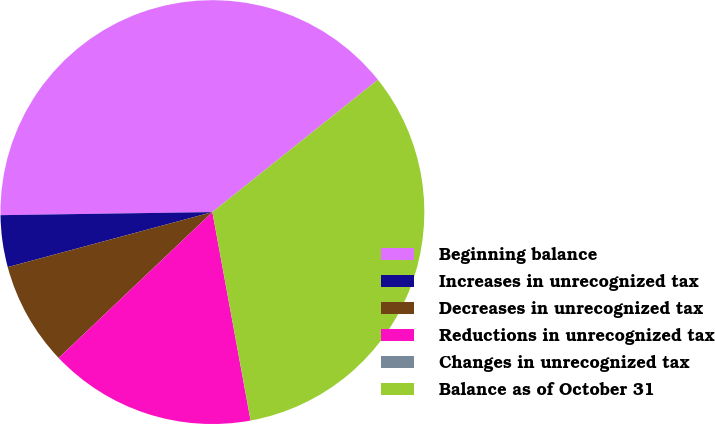Convert chart to OTSL. <chart><loc_0><loc_0><loc_500><loc_500><pie_chart><fcel>Beginning balance<fcel>Increases in unrecognized tax<fcel>Decreases in unrecognized tax<fcel>Reductions in unrecognized tax<fcel>Changes in unrecognized tax<fcel>Balance as of October 31<nl><fcel>39.49%<fcel>3.95%<fcel>7.9%<fcel>15.8%<fcel>0.01%<fcel>32.84%<nl></chart> 